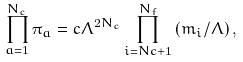Convert formula to latex. <formula><loc_0><loc_0><loc_500><loc_500>\prod _ { a = 1 } ^ { N _ { c } } \pi _ { a } = c \Lambda ^ { 2 N _ { c } } \prod _ { i = N c + 1 } ^ { N _ { f } } \left ( m _ { i } / \Lambda \right ) ,</formula> 